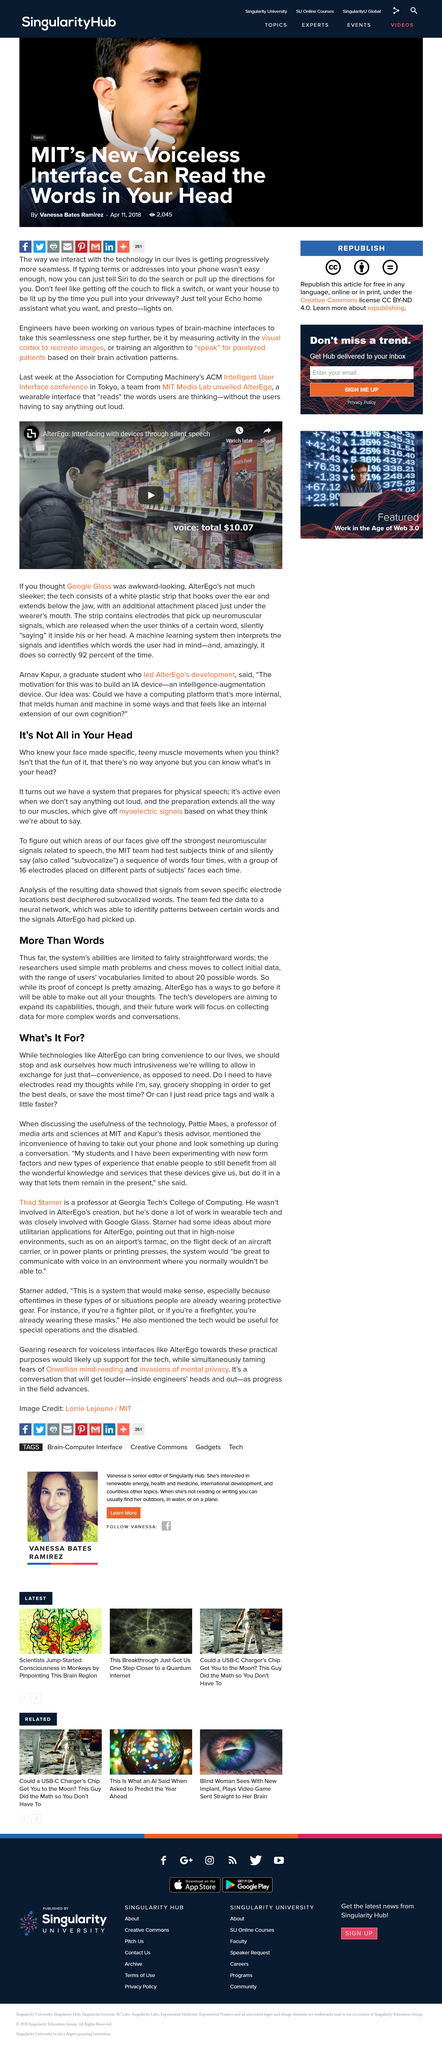Give some essential details in this illustration. Myoelectric signals are based on the thoughts and intentions of our muscles, indicating what our muscles believe we are about to say or do. In the future, the developer's work will be focused on collecting data for more complex words and conversations. Professor Pattie Maes is affiliated with the Massachusetts Institute of Technology (MIT). The New Voiceless Interface has the ability to read the words in a person's head, allowing for hands-free communication and increased convenience. It is possible to instruct Echo to switch on the lights using the command 'Can you tell Echo to turn on the lights? Yes you can..'. 